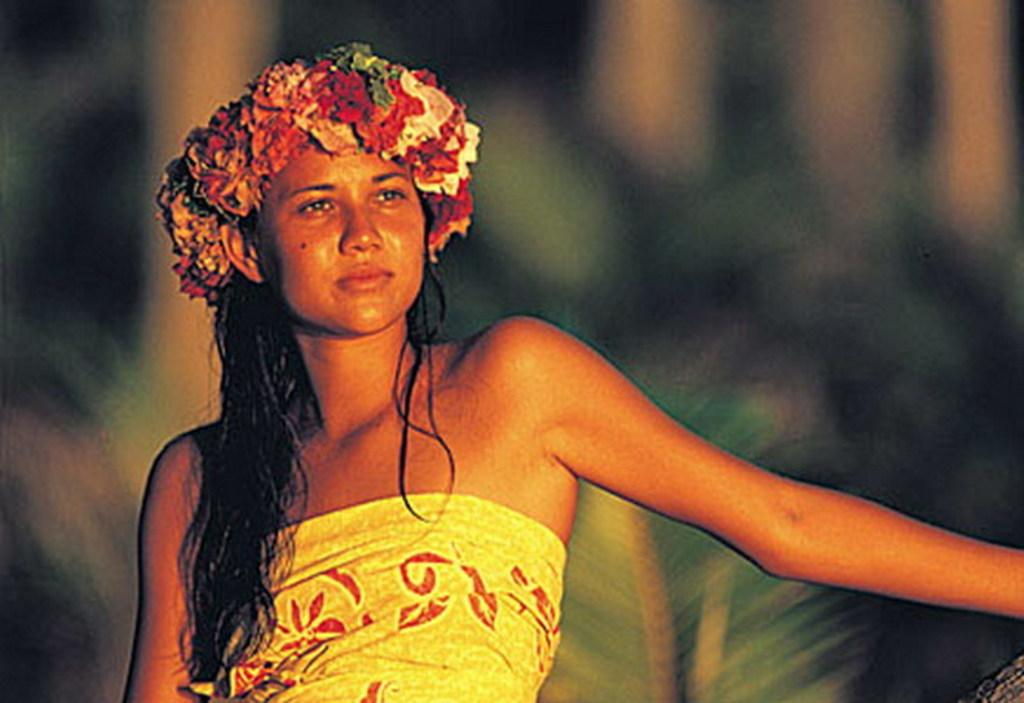Who is the main subject in the image? There is a woman in the image. What is unique about the woman's appearance? The woman is wearing flowers on her head. Can you describe the background of the image? The background of the image is blurry. What type of chess piece is the woman holding in the image? There is no chess piece present in the image. Can you describe the woman's expression while she is kissing someone in the image? There is no kissing scene depicted in the image; the woman is simply wearing flowers on her head. 